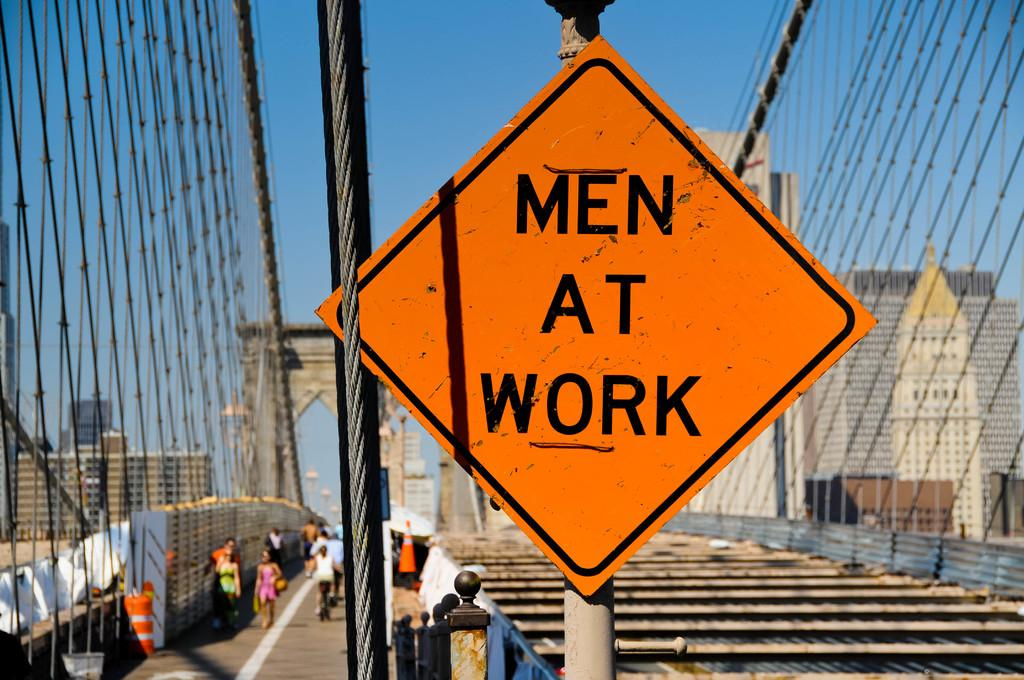Provide a one-sentence caption for the provided image. A large orange Men At Work sign on a bridge under construction. 